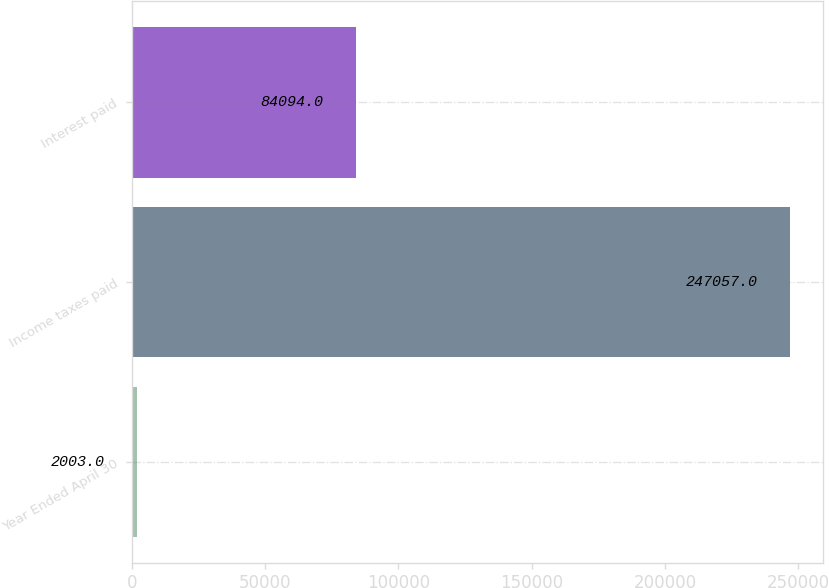Convert chart to OTSL. <chart><loc_0><loc_0><loc_500><loc_500><bar_chart><fcel>Year Ended April 30<fcel>Income taxes paid<fcel>Interest paid<nl><fcel>2003<fcel>247057<fcel>84094<nl></chart> 